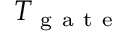<formula> <loc_0><loc_0><loc_500><loc_500>T _ { g a t e }</formula> 